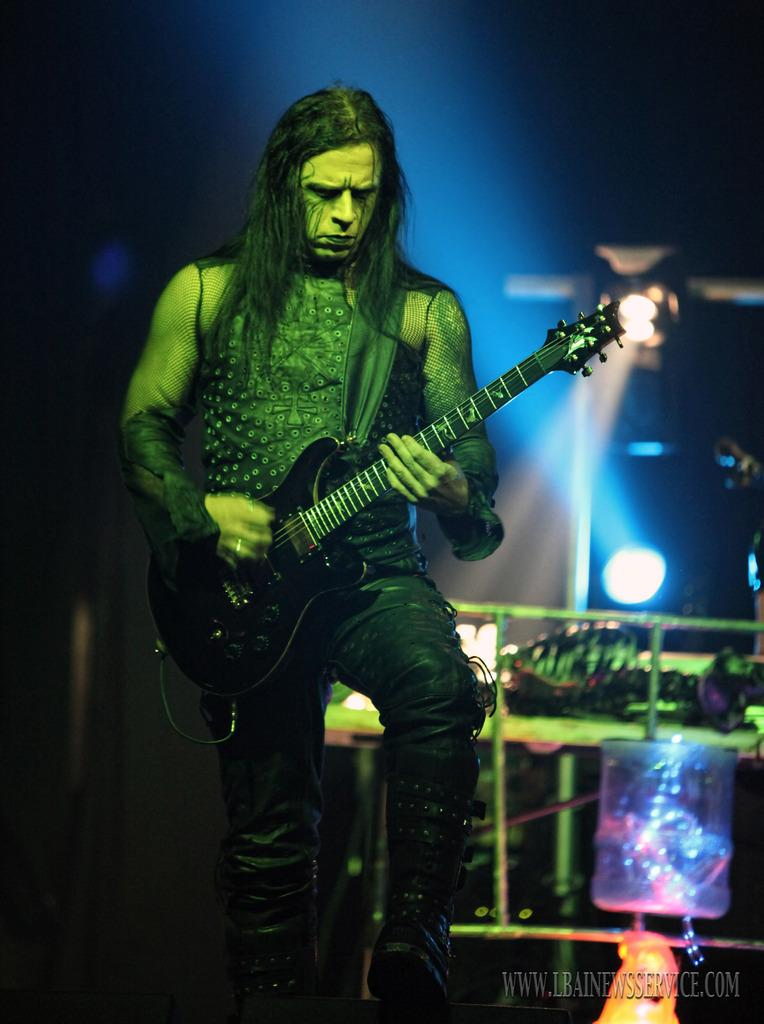What is the main subject of the image? There is a man in the image. What is the man doing in the image? The man is standing and catching a guitar in his hand. Is there any text or logo in the image? Yes, there is a watermark in the image. What can be seen providing illumination in the image? There is a light in the image. What type of business is being conducted in the image? There is no indication of any business being conducted in the image; it primarily features a man catching a guitar. Can you see a drum in the image? No, there is no drum present in the image. 